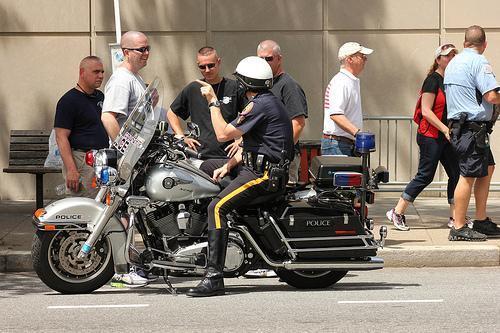How many people total are in the photo?
Give a very brief answer. 8. How many people are wearing sunglasses?
Give a very brief answer. 3. 